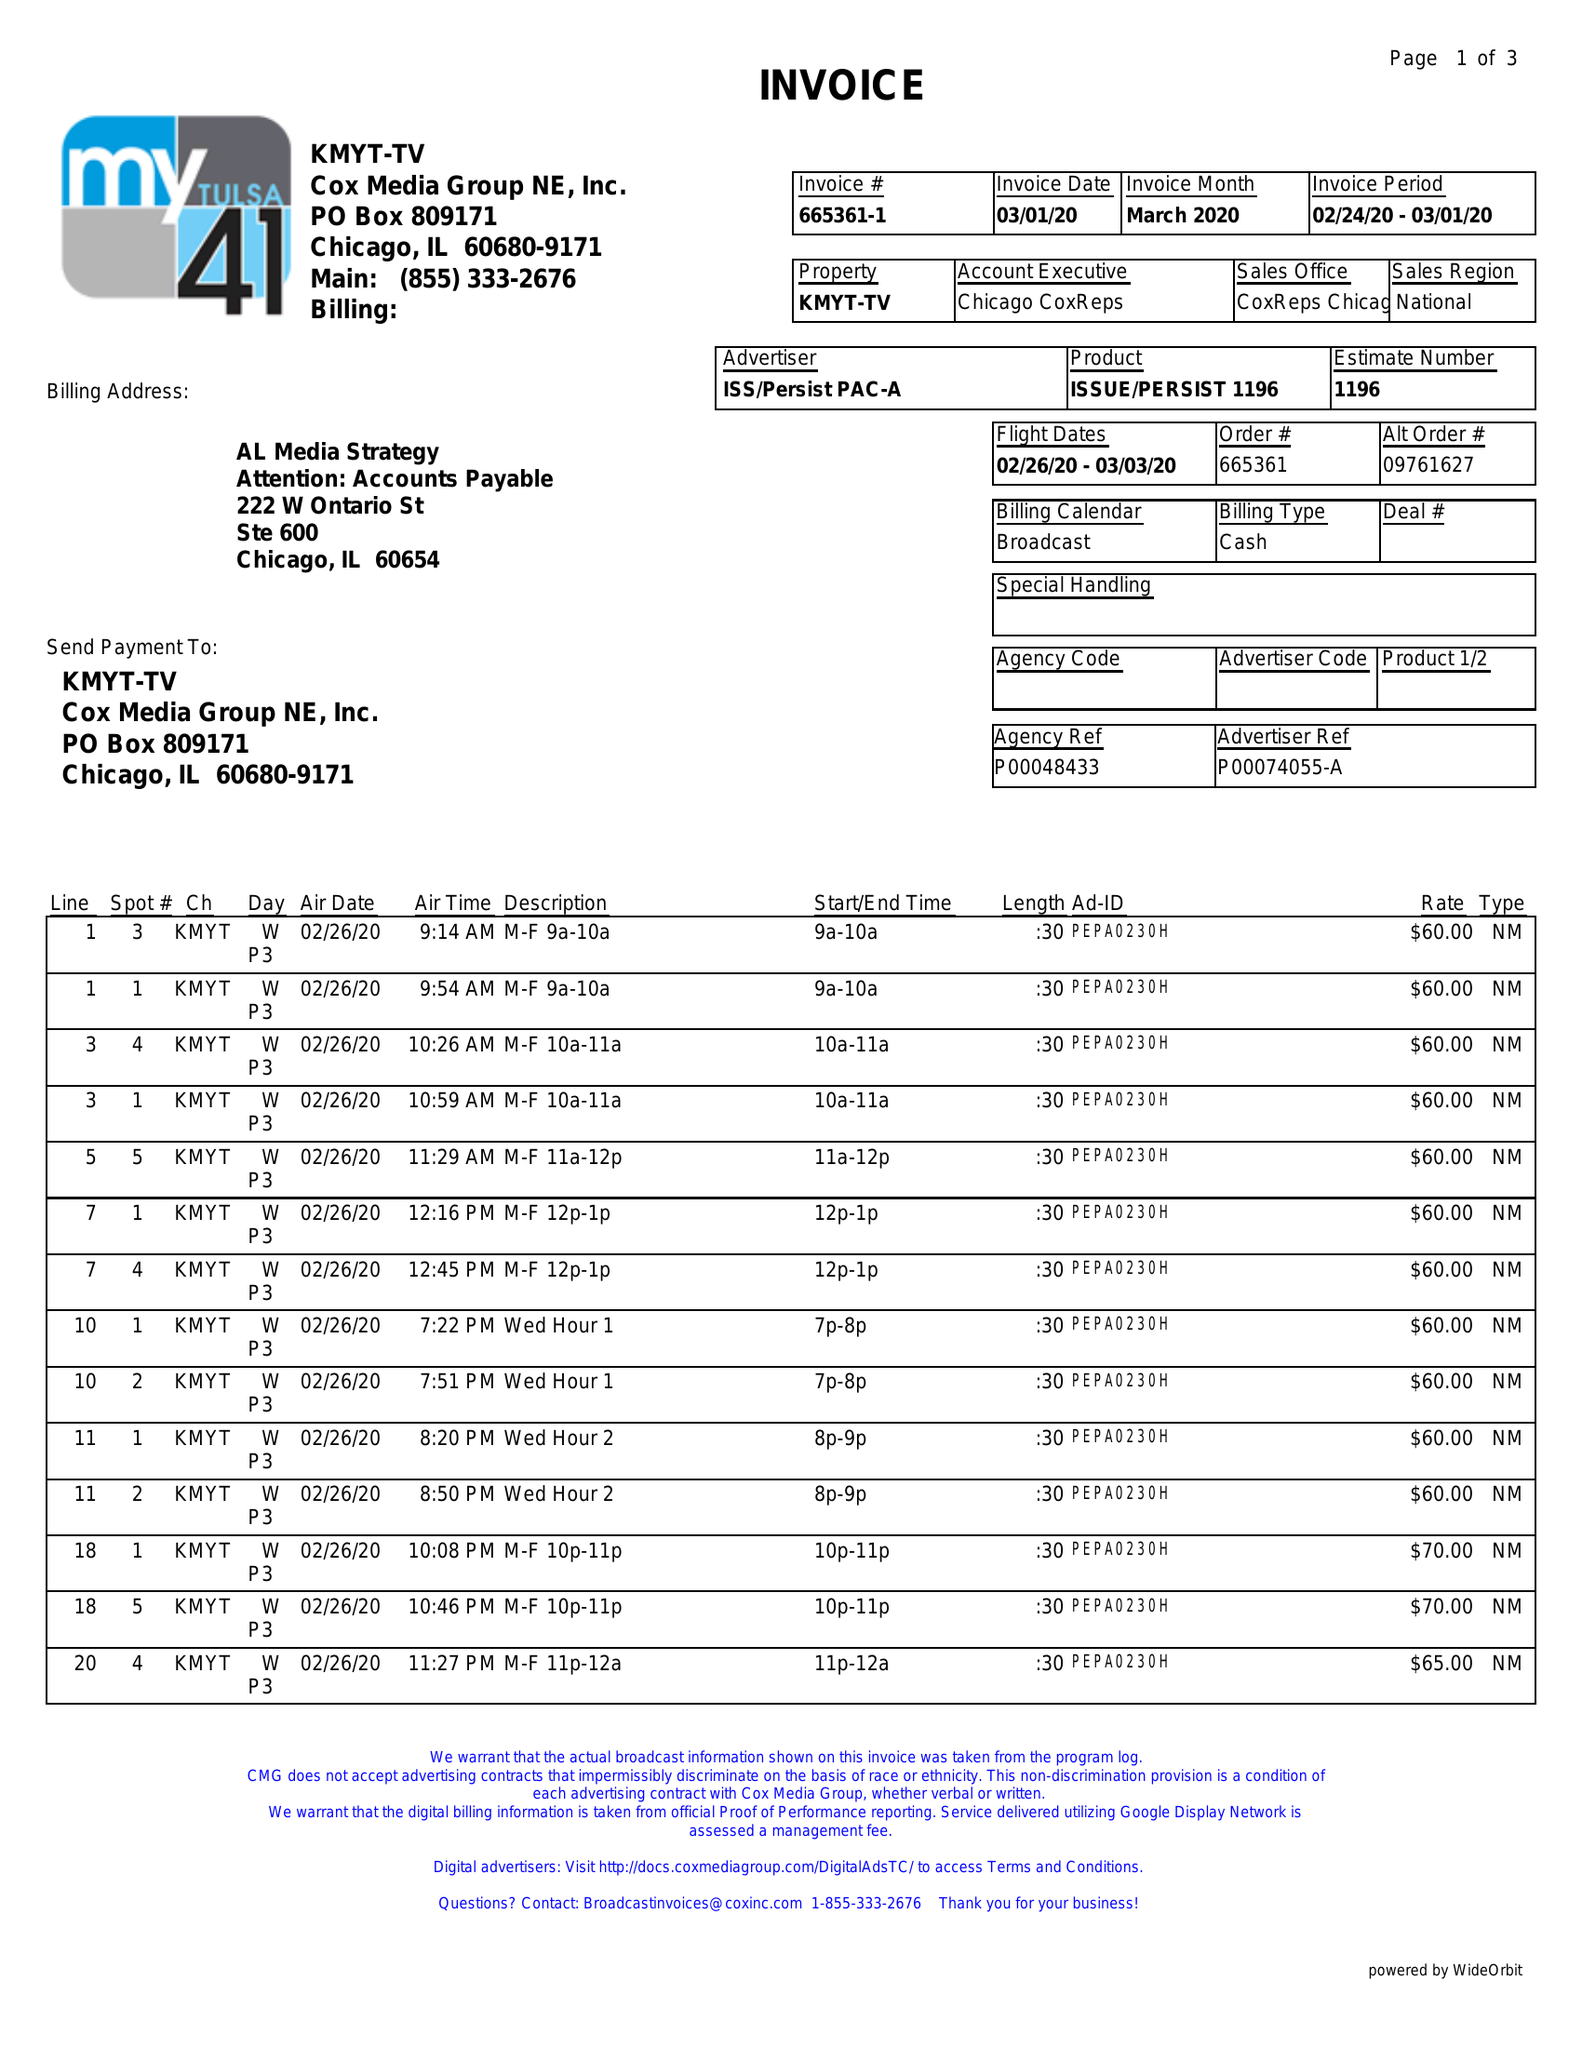What is the value for the flight_from?
Answer the question using a single word or phrase. 02/26/20 